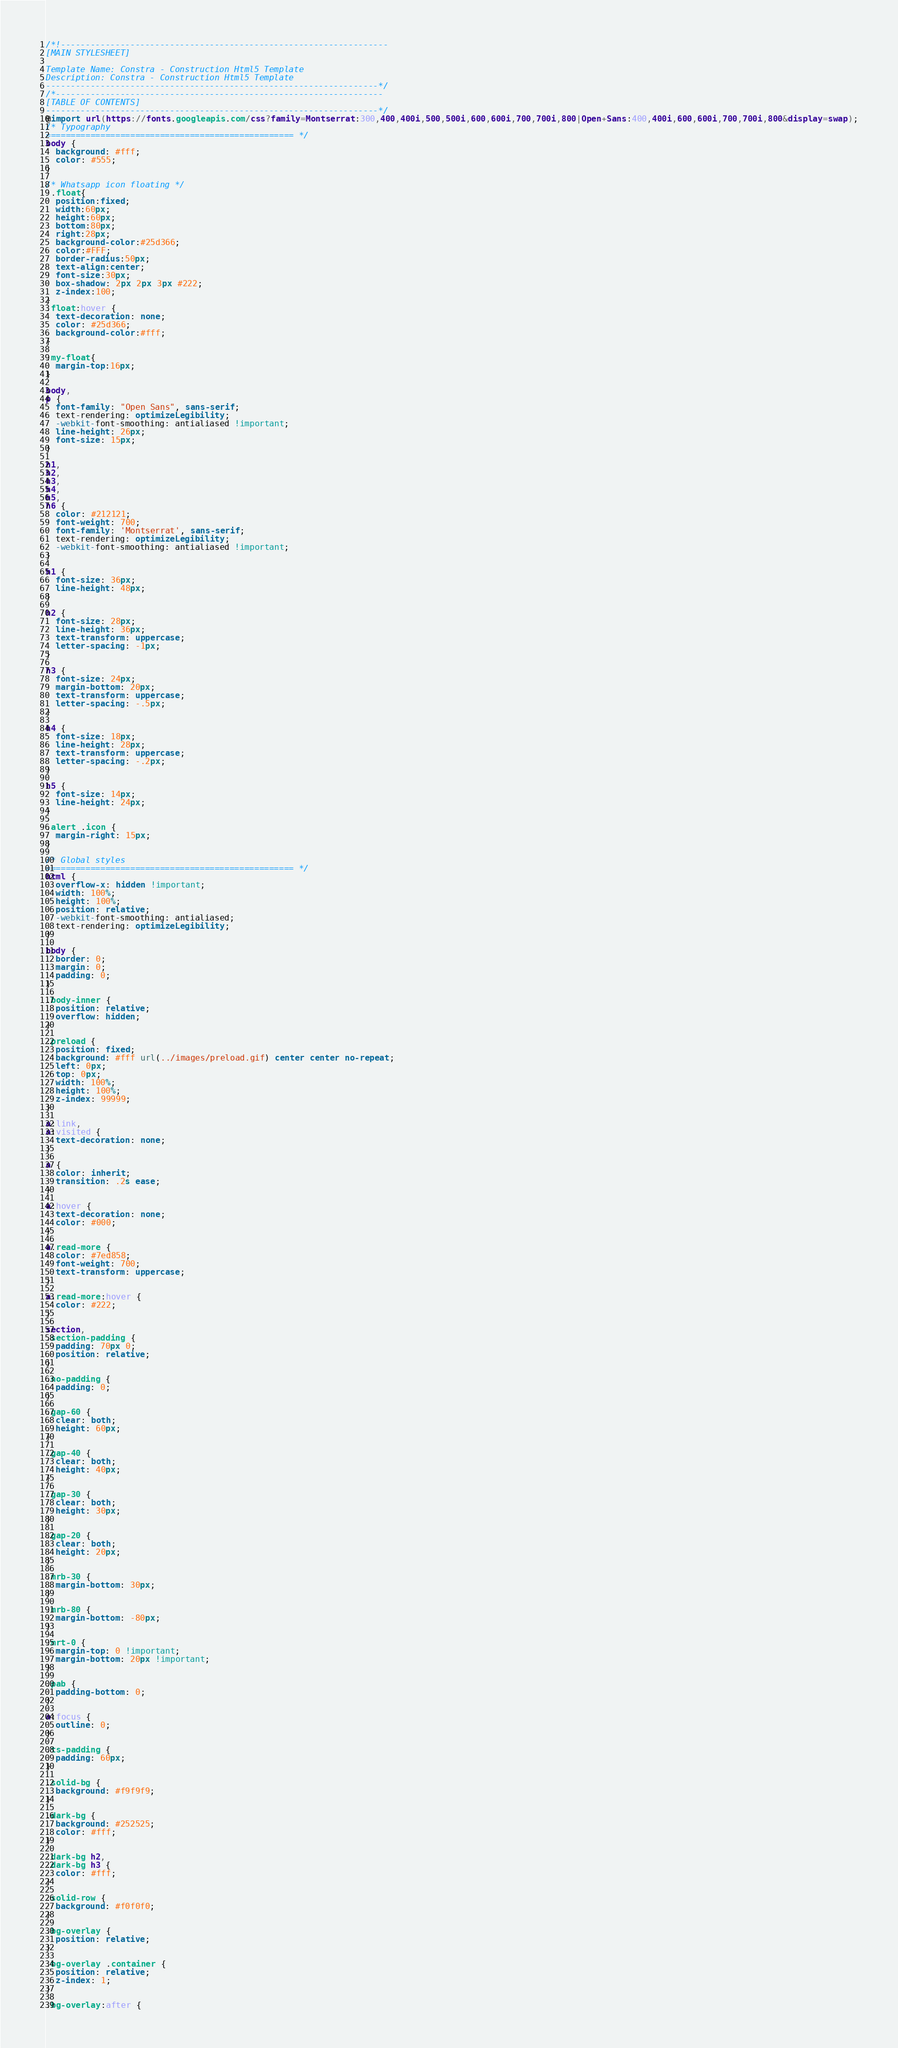<code> <loc_0><loc_0><loc_500><loc_500><_CSS_>/*!------------------------------------------------------------------
[MAIN STYLESHEET]

Template Name: Constra - Construction Html5 Template
Description: Constra - Construction Html5 Template
-------------------------------------------------------------------*/
/*------------------------------------------------------------------
[TABLE OF CONTENTS]
-------------------------------------------------------------------*/
@import url(https://fonts.googleapis.com/css?family=Montserrat:300,400,400i,500,500i,600,600i,700,700i,800|Open+Sans:400,400i,600,600i,700,700i,800&display=swap);
/* Typography
================================================== */
body {
  background: #fff;
  color: #555;
}

/* Whatsapp icon floating */
 .float{
  position:fixed;
  width:60px;
  height:60px;
  bottom:80px;
  right:28px;
  background-color:#25d366;
  color:#FFF;
  border-radius:50px;
  text-align:center;
  font-size:30px;
  box-shadow: 2px 2px 3px #222;
  z-index:100;
}
.float:hover {
  text-decoration: none;
  color: #25d366;
  background-color:#fff;
}

.my-float{
  margin-top:16px;
}

body,
p {
  font-family: "Open Sans", sans-serif;
  text-rendering: optimizeLegibility;
  -webkit-font-smoothing: antialiased !important;
  line-height: 26px;
  font-size: 15px;
}

h1,
h2,
h3,
h4,
h5,
h6 {
  color: #212121;
  font-weight: 700;
  font-family: 'Montserrat', sans-serif;
  text-rendering: optimizeLegibility;
  -webkit-font-smoothing: antialiased !important;
}

h1 {
  font-size: 36px;
  line-height: 48px;
}

h2 {
  font-size: 28px;
  line-height: 36px;
  text-transform: uppercase;
  letter-spacing: -1px;
}

h3 {
  font-size: 24px;
  margin-bottom: 20px;
  text-transform: uppercase;
  letter-spacing: -.5px;
}

h4 {
  font-size: 18px;
  line-height: 28px;
  text-transform: uppercase;
  letter-spacing: -.2px;
}

h5 {
  font-size: 14px;
  line-height: 24px;
}

.alert .icon {
  margin-right: 15px;
}

/* Global styles
================================================== */
html {
  overflow-x: hidden !important;
  width: 100%;
  height: 100%;
  position: relative;
  -webkit-font-smoothing: antialiased;
  text-rendering: optimizeLegibility;
}

body {
  border: 0;
  margin: 0;
  padding: 0;
}

.body-inner {
  position: relative;
  overflow: hidden;
}

.preload {
  position: fixed;
  background: #fff url(../images/preload.gif) center center no-repeat;
  left: 0px;
  top: 0px;
  width: 100%;
  height: 100%;
  z-index: 99999;
}

a:link,
a:visited {
  text-decoration: none;
}

a {
  color: inherit;
  transition: .2s ease;
}

a:hover {
  text-decoration: none;
  color: #000;
}

a.read-more {
  color: #7ed858;
  font-weight: 700;
  text-transform: uppercase;
}

a.read-more:hover {
  color: #222;
}

section,
.section-padding {
  padding: 70px 0;
  position: relative;
}

.no-padding {
  padding: 0;
}

.gap-60 {
  clear: both;
  height: 60px;
}

.gap-40 {
  clear: both;
  height: 40px;
}

.gap-30 {
  clear: both;
  height: 30px;
}

.gap-20 {
  clear: both;
  height: 20px;
}

.mrb-30 {
  margin-bottom: 30px;
}

.mrb-80 {
  margin-bottom: -80px;
}

.mrt-0 {
  margin-top: 0 !important;
  margin-bottom: 20px !important;
}

.pab {
  padding-bottom: 0;
}

a:focus {
  outline: 0;
}

.ts-padding {
  padding: 60px;
}

.solid-bg {
  background: #f9f9f9;
}

.dark-bg {
  background: #252525;
  color: #fff;
}

.dark-bg h2,
.dark-bg h3 {
  color: #fff;
}

.solid-row {
  background: #f0f0f0;
}

.bg-overlay {
  position: relative;
}

.bg-overlay .container {
  position: relative;
  z-index: 1;
}

.bg-overlay:after {</code> 